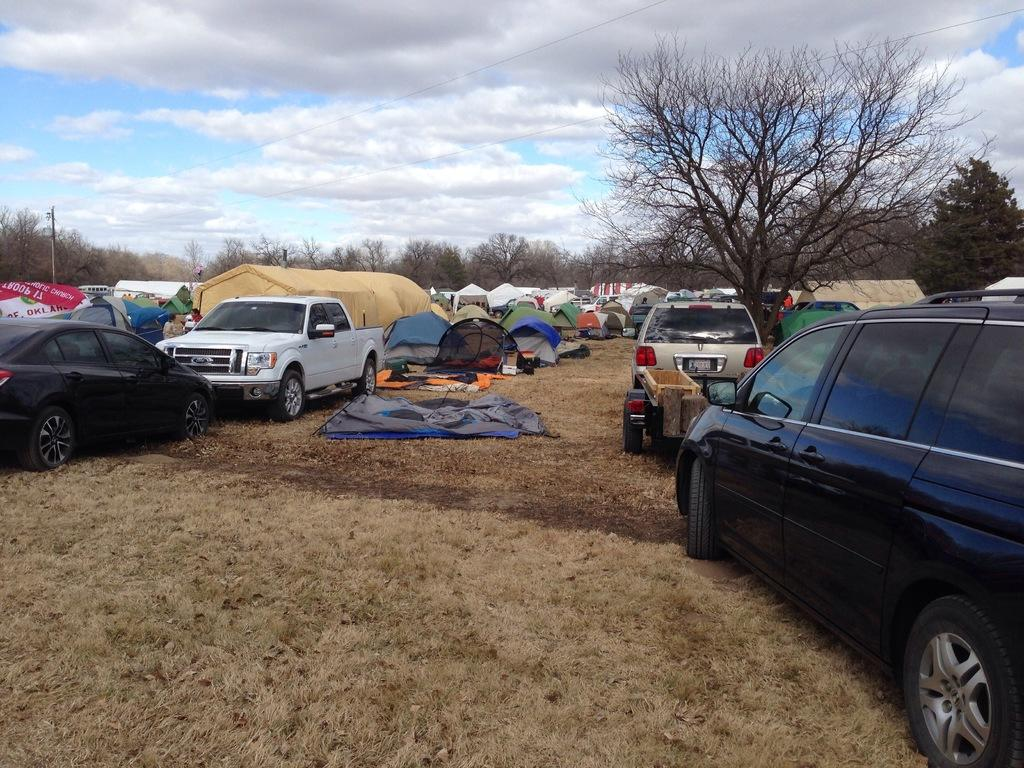What types of objects are present in the image? There are vehicles in the image. What can be seen in the background of the image? There are tent houses and trees in the background of the image. What is visible above the vehicles and tent houses? The sky is visible in the image. How would you describe the sky in the image? The sky appears to be cloudy in the image. Can you see a hand holding a feather in the image? There is no hand or feather present in the image. 